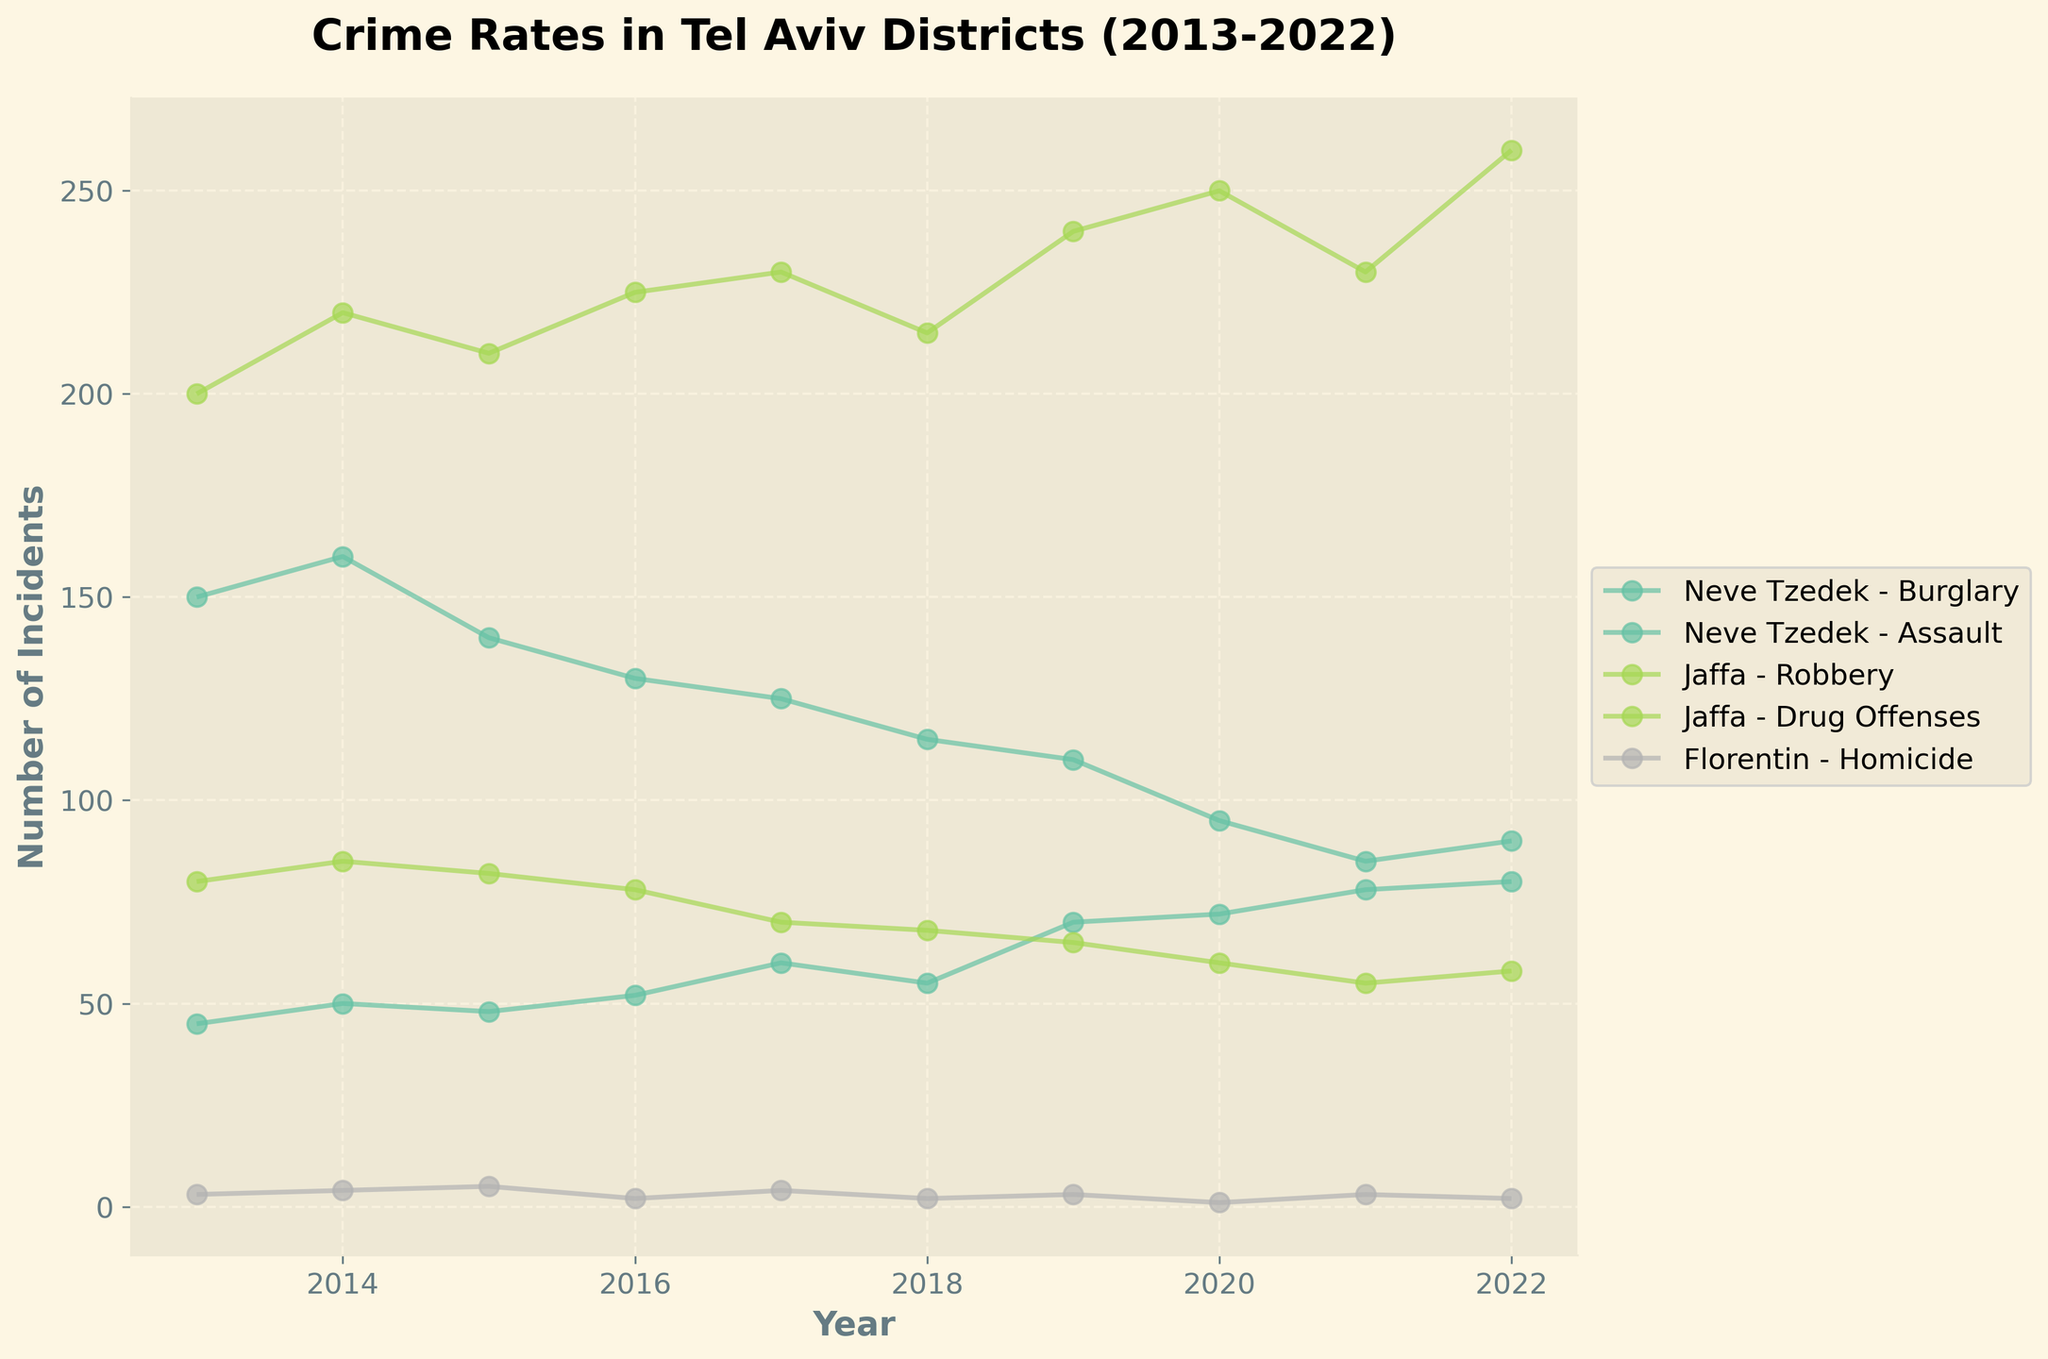What's the title of the plot? The title of the plot is usually prominently displayed at the top of the figure. By observing the plot, you can read the title directly.
Answer: Crime Rates in Tel Aviv Districts (2013-2022) What does the x-axis represent? The x-axis typically runs horizontally along the bottom of the plot. By looking at the labels along this axis, you can determine what it represents.
Answer: Year What does the y-axis represent? The y-axis runs vertically along the side of the plot. The labels and legend usually specify what this axis represents.
Answer: Number of Incidents What colors are used to distinguish the different districts? By examining the plot, you'll notice different colored lines corresponding to each district; these are generally indicated in the legend box.
Answer: Various colors from the colormap 'Set2' Between which years did Neve Tzedek see the largest drop in burglary incidents? To answer this, observe the Neve Tzedek - Burglary line. Identify the years between which the number of incidents drops the most significantly.
Answer: 2014 to 2020 What is the general trend of drug offenses in Jaffa over the period shown? Look at the line corresponding to Jaffa - Drug Offenses. Note the direction and changes in the slope to describe the overall trend.
Answer: Increasing In which year did Florentin experience the highest number of homicides? To find this out, look at the highest peak on the Florentin - Homicide line and note the corresponding year on the x-axis.
Answer: 2015 Which district had the most fluctuating number of robbery incidents over the decade? Review the lines corresponding to robbery incidents in each district and compare their volatility to identify the most fluctuating one.
Answer: Jaffa Compare the number of burglary incidents in Neve Tzedek in 2013 and 2022. How much did it decrease? Subtract the number of burglary incidents in 2022 from that in 2013 for Neve Tzedek.
Answer: 60 Which type of crime showed the most significant overall increase in Jaffa from 2013 to 2022? Examine the trends for each type of crime in Jaffa over the years and identify which one has the largest difference between the beginning and end years.
Answer: Drug Offenses 